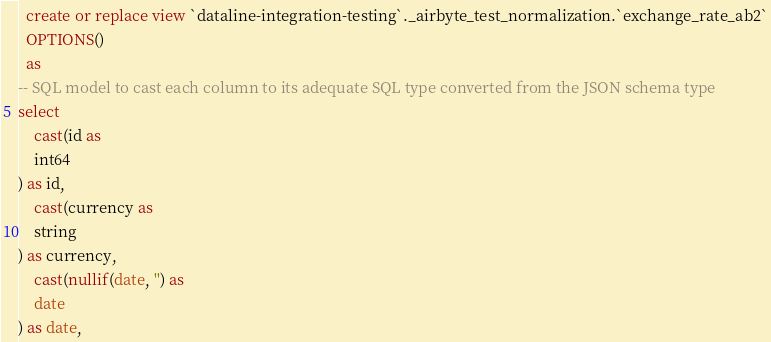<code> <loc_0><loc_0><loc_500><loc_500><_SQL_>

  create or replace view `dataline-integration-testing`._airbyte_test_normalization.`exchange_rate_ab2`
  OPTIONS()
  as 
-- SQL model to cast each column to its adequate SQL type converted from the JSON schema type
select
    cast(id as 
    int64
) as id,
    cast(currency as 
    string
) as currency,
    cast(nullif(date, '') as 
    date
) as date,</code> 